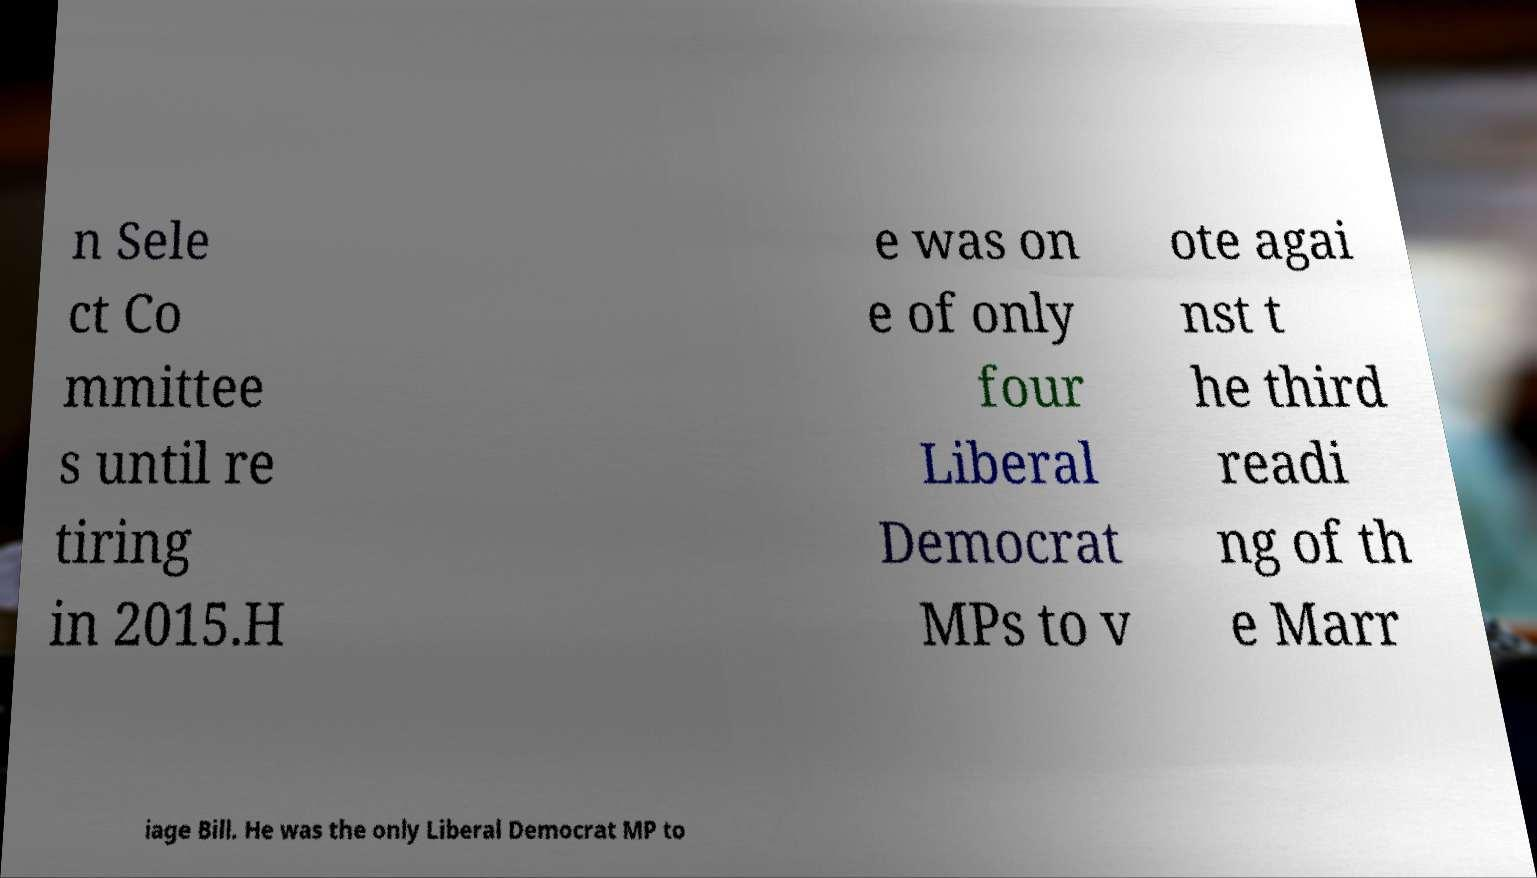Please identify and transcribe the text found in this image. n Sele ct Co mmittee s until re tiring in 2015.H e was on e of only four Liberal Democrat MPs to v ote agai nst t he third readi ng of th e Marr iage Bill. He was the only Liberal Democrat MP to 